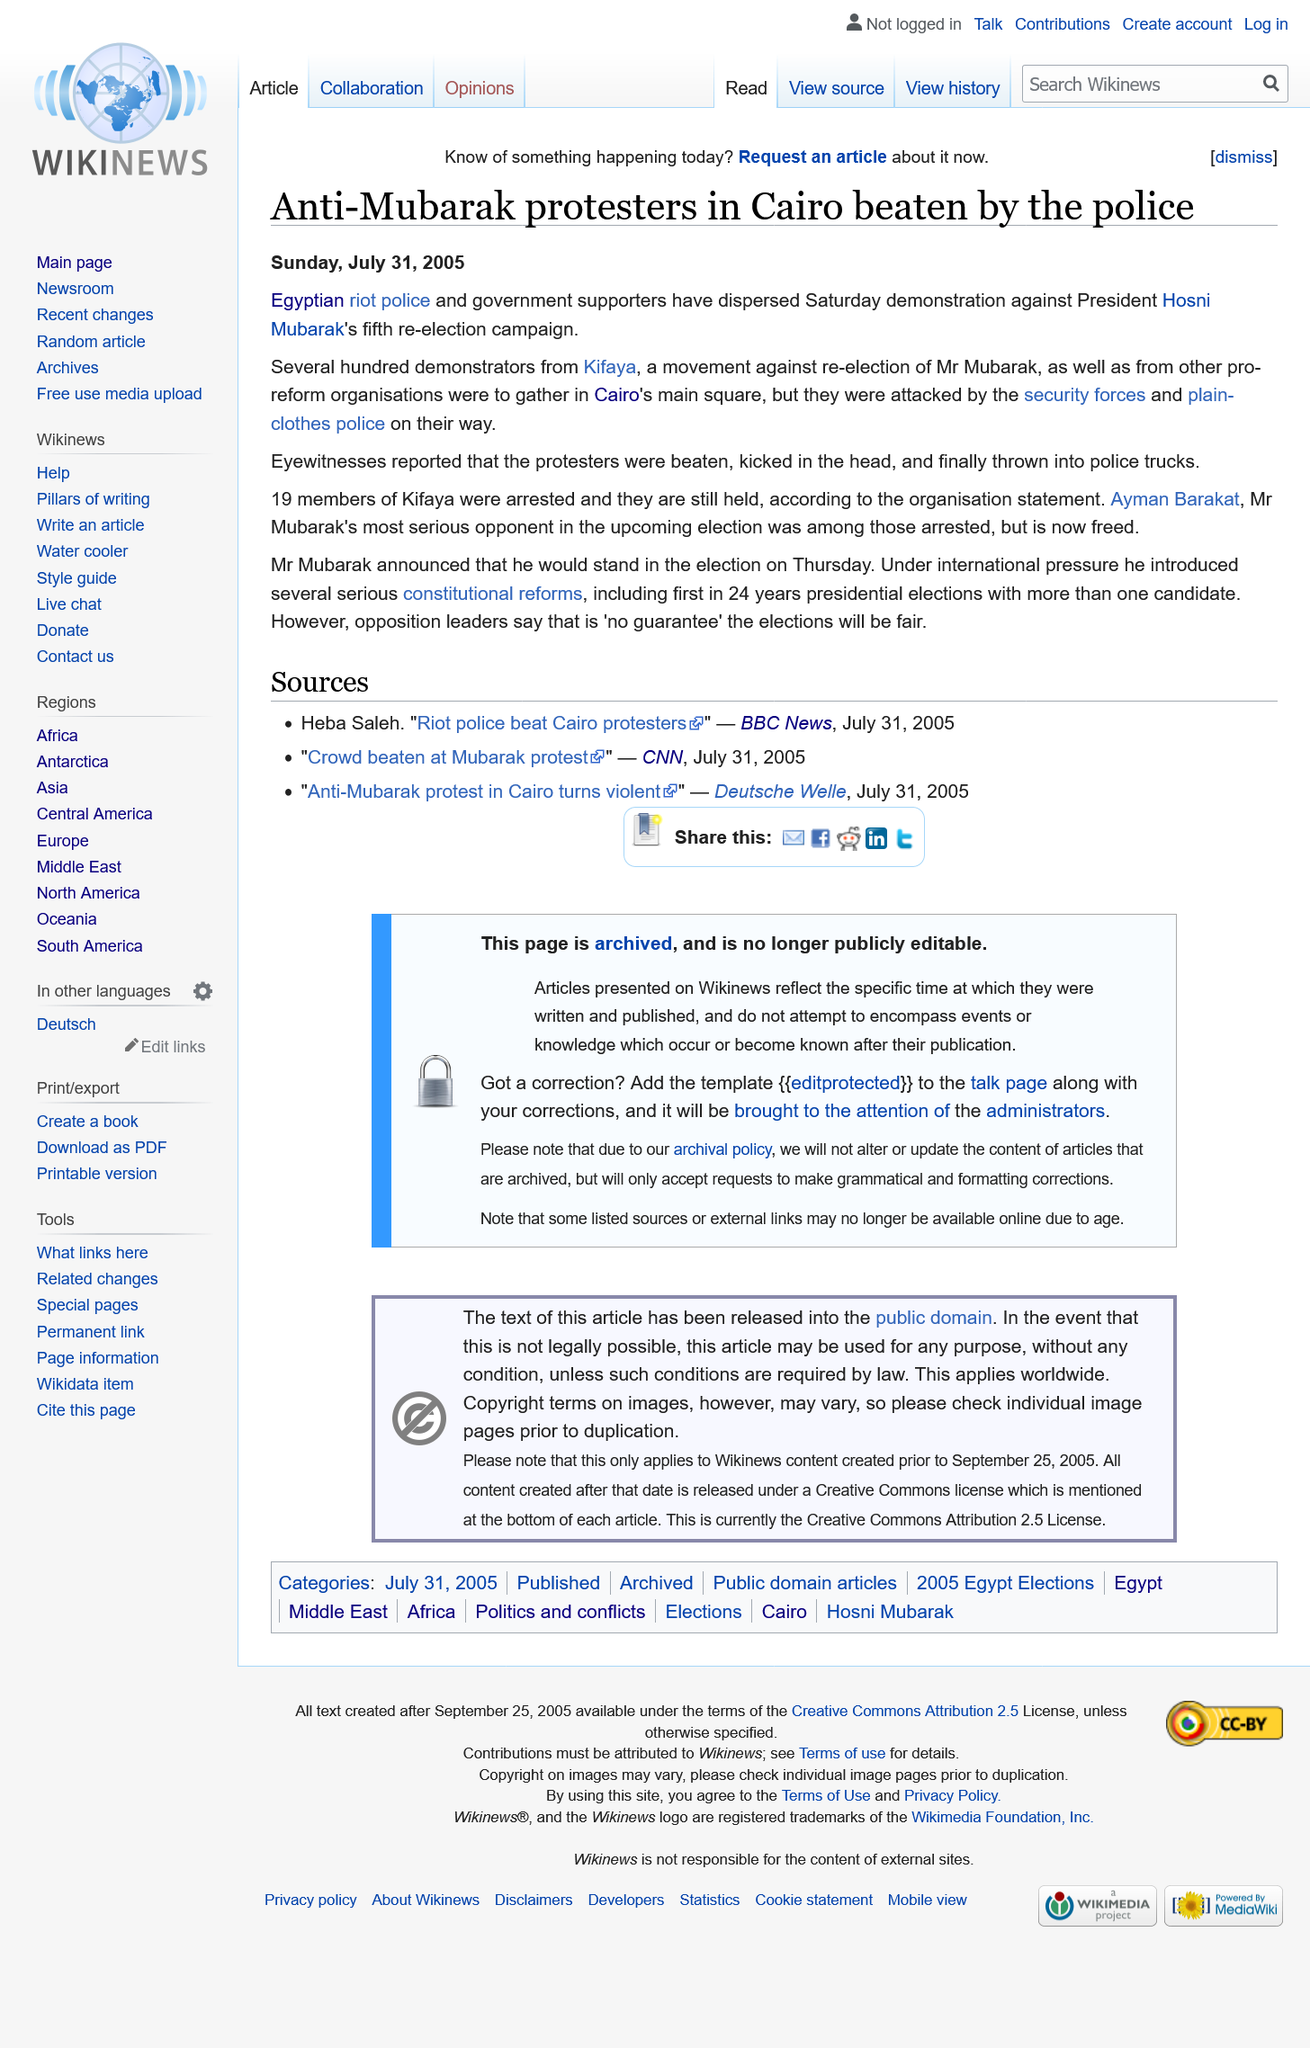Mention a couple of crucial points in this snapshot. Eyewitness reports indicate that the protesters were subjected to physical abuse, including being beaten, kicked in the head, and forcibly thrown into police trucks. The protest occurred in Cairo. The protesters were beaten by Egyptian riot police. 